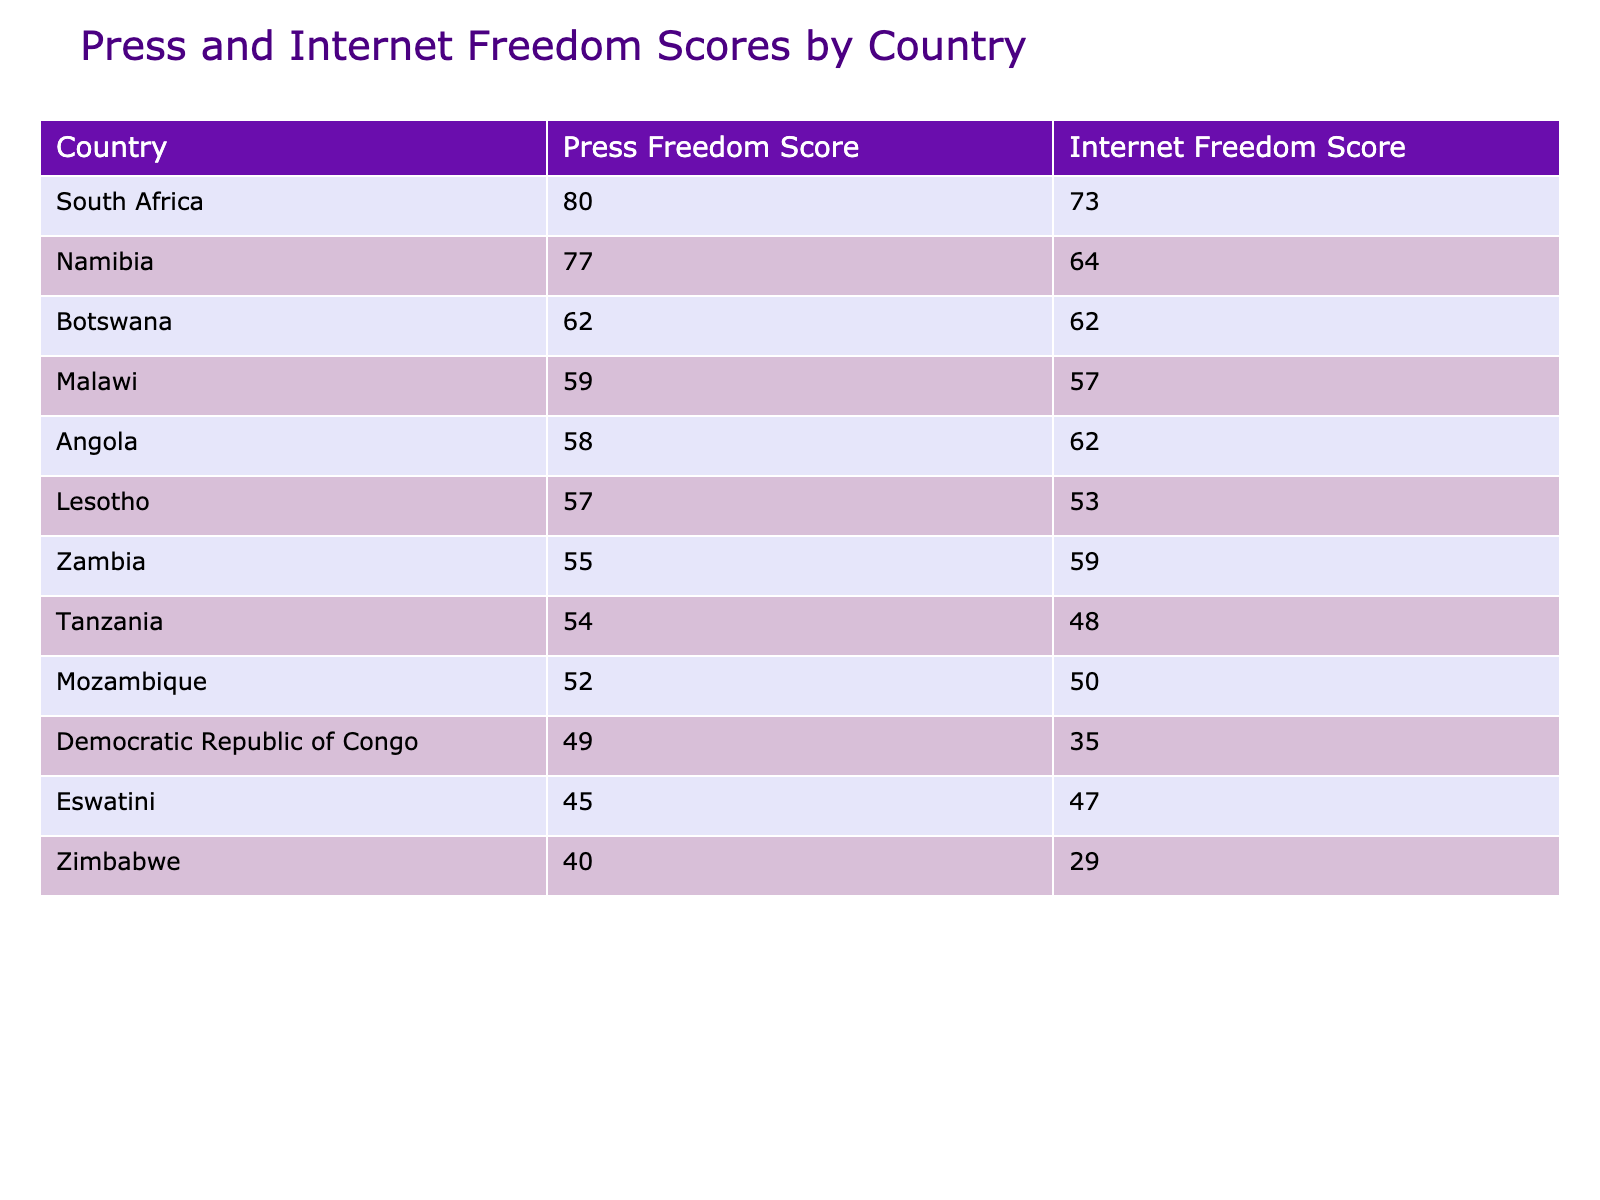What is the Press Freedom Score for Namibia? The Press Freedom Score for Namibia is listed in the table as 77, which is located in the relevant row for Namibia.
Answer: 77 Which country has the highest Internet Freedom Score? In the table, the Internet Freedom Scores are listed for each country. By comparing the values, South Africa has the highest score of 73.
Answer: 73 Is the Press Freedom Score for Zimbabwe greater than the score for Malawi? The Press Freedom Score for Zimbabwe is 40 and for Malawi is 59. Since 40 is less than 59, the statement is false.
Answer: No What is the average Press Freedom Score of the countries listed in the table? The Press Freedom Scores of the countries are: 40, 80, 77, 55, 52, 62, 59, 57, 45, 58, 54, and 49. Adding these scores gives 625, and there are 12 countries, so the average is 625/12, which is approximately 52.08.
Answer: 52.08 Which country has the lowest Censorship Level, and what is its Press Freedom Score? By reviewing the Censorship Level column, South Africa, Namibia, Botswana, and Malawi all have a low level of censorship. South Africa has a Press Freedom Score of 80, Namibia 77, Botswana 62, and Malawi 59. Of these, South Africa has the highest score. Therefore, the answer is South Africa with a score of 80.
Answer: South Africa, 80 Are all countries listed in the table under moderate restrictions for media ownership? The table shows different levels of Media Ownership Restrictions: Zimbabwe has moderate, while South Africa, Namibia, Botswana, and Malawi have low, and Eswatini has high. Thus, the statement is false.
Answer: No Which country has both a high Press Freedom Score and Internet Freedom Score? By checking the scores, South Africa has a high Press Freedom Score of 80 and Internet Freedom Score of 73. Therefore, South Africa fits the criteria perfectly.
Answer: South Africa How many countries have a Press Freedom Score below 50? The countries with a Press Freedom Score below 50 are Zimbabwe (40), Tanzania (54), and the Democratic Republic of Congo (49), which totals three countries.
Answer: 3 